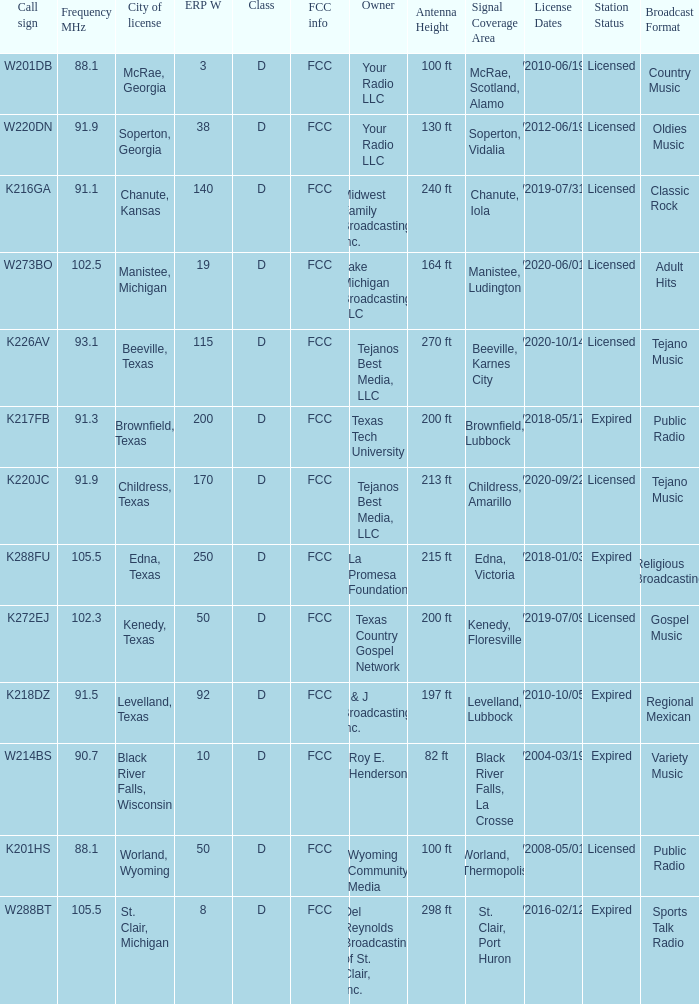What is City of License, when ERP W is greater than 3, and when Call Sign is K218DZ? Levelland, Texas. 